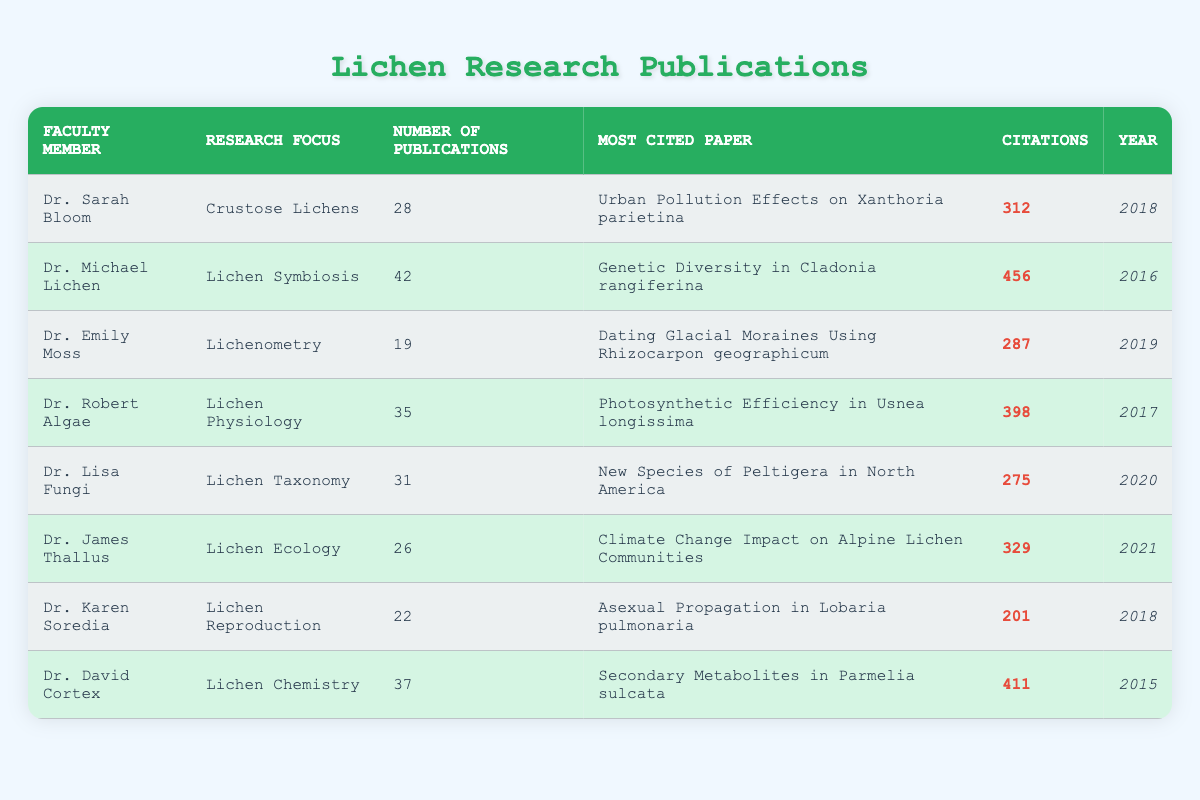What is the research focus of Dr. Michael Lichen? In the table, under the "Research Focus" column, we locate Dr. Michael Lichen’s name, which is in the second row. The corresponding entry in the "Research Focus" column is "Lichen Symbiosis."
Answer: Lichen Symbiosis How many publications does Dr. Sarah Bloom have? In the first row of the table, we find Dr. Sarah Bloom listed. Under the "Number of Publications" column, her entry shows 28 publications.
Answer: 28 Which faculty member has the highest number of citations, and what is that citation count? To determine which faculty member has the highest citations, we look at the "Citations" column. Scanning through the numbers, we find that Dr. Michael Lichen has the highest count at 456 citations.
Answer: Dr. Michael Lichen, 456 What is the average number of publications among all faculty members? First, we total the number of publications: 28 + 42 + 19 + 35 + 31 + 26 + 22 + 37 = 300. There are 8 faculty members, so we calculate the average as 300 / 8 = 37.5.
Answer: 37.5 Did any faculty member publish a paper in 2020? By examining the "Year" column, we see that Dr. Lisa Fungi published her paper in 2020. Therefore, the answer is yes.
Answer: Yes Which faculty member is associated with the topic of lichen reproduction? Looking at the "Research Focus" column, we find Dr. Karen Soredia associated with "Lichen Reproduction."
Answer: Dr. Karen Soredia How many citations does Dr. Emily Moss's most cited paper have compared to Dr. Robert Algae's? Dr. Emily Moss has 287 citations for her paper, while Dr. Robert Algae has 398 citations. The difference is 398 - 287 = 111 citations, meaning Robert Algae’s paper is cited more.
Answer: 111 What is the most cited paper in the table, and who authored it? Scanning the "Most Cited Paper" and "Citations" columns, we find that "Genetic Diversity in Cladonia rangiferina" by Dr. Michael Lichen has the highest citation count of 456.
Answer: "Genetic Diversity in Cladonia rangiferina," Dr. Michael Lichen Which faculty member has more publications, Dr. David Cortex or Dr. James Thallus? We check the "Number of Publications" for Dr. David Cortex, which is 37, and for Dr. James Thallus, which is 26. Comparing these values, Dr. David Cortex has more publications.
Answer: Dr. David Cortex 